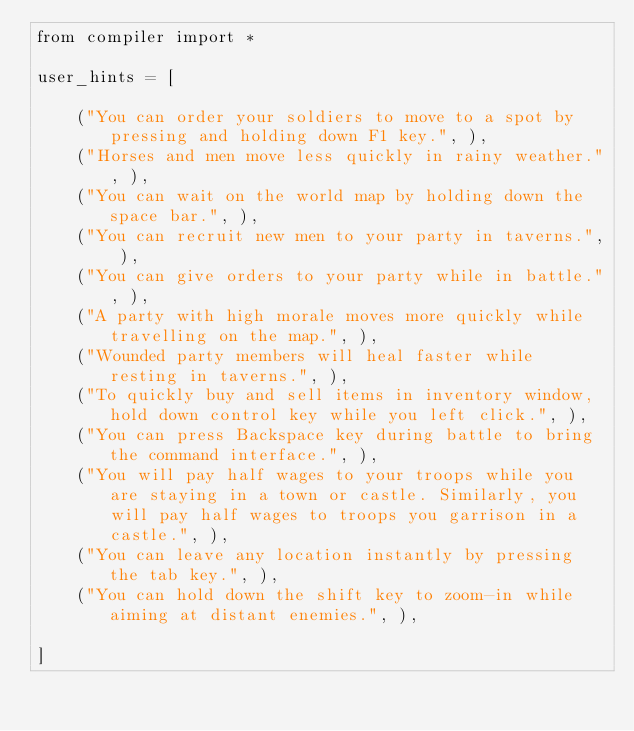Convert code to text. <code><loc_0><loc_0><loc_500><loc_500><_Python_>from compiler import *

user_hints = [

    ("You can order your soldiers to move to a spot by pressing and holding down F1 key.", ),
    ("Horses and men move less quickly in rainy weather.", ),
    ("You can wait on the world map by holding down the space bar.", ),
    ("You can recruit new men to your party in taverns.", ),
    ("You can give orders to your party while in battle.", ),
    ("A party with high morale moves more quickly while travelling on the map.", ),
    ("Wounded party members will heal faster while resting in taverns.", ),
    ("To quickly buy and sell items in inventory window, hold down control key while you left click.", ),
    ("You can press Backspace key during battle to bring the command interface.", ),
    ("You will pay half wages to your troops while you are staying in a town or castle. Similarly, you will pay half wages to troops you garrison in a castle.", ),
    ("You can leave any location instantly by pressing the tab key.", ),
    ("You can hold down the shift key to zoom-in while aiming at distant enemies.", ),

]</code> 